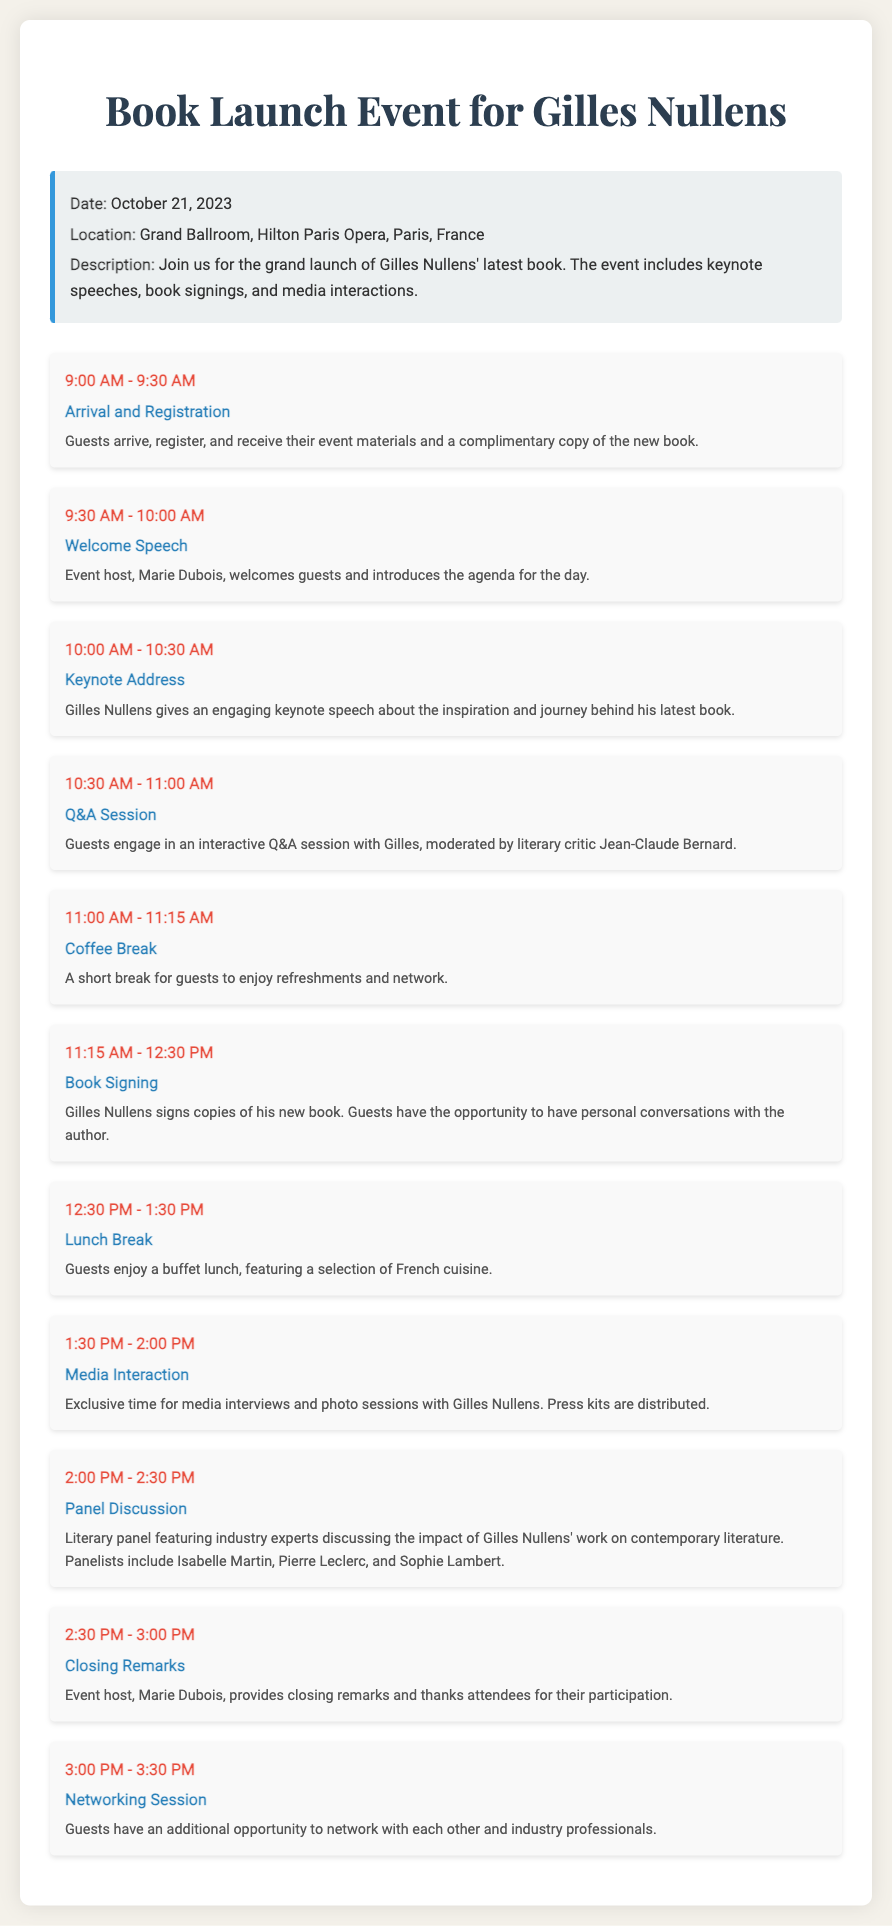What is the date of the event? The date is specified in the document as October 21, 2023.
Answer: October 21, 2023 What is the location of the book launch? The location provided in the document is the Grand Ballroom, Hilton Paris Opera, Paris, France.
Answer: Grand Ballroom, Hilton Paris Opera, Paris, France Who gives the keynote address? The document states that Gilles Nullens gives the keynote speech about his book.
Answer: Gilles Nullens How long is the lunch break? The document specifies that the lunch break lasts for one hour, from 12:30 PM to 1:30 PM.
Answer: 1 hour What activity follows the coffee break? According to the itinerary, the book signing follows the coffee break.
Answer: Book Signing Who is the host of the event? The event host is mentioned in the document as Marie Dubois.
Answer: Marie Dubois How many people are involved in the panel discussion? The document lists three panelists discussing Gilles Nullens' work during the panel discussion.
Answer: Three At what time does the media interaction occur? The document states that media interaction takes place from 1:30 PM to 2:00 PM.
Answer: 1:30 PM - 2:00 PM What is included in the event materials? Guests receive event materials along with a complimentary copy of the new book.
Answer: Complimentary copy of the new book 